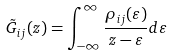<formula> <loc_0><loc_0><loc_500><loc_500>\tilde { G } _ { i j } ( z ) = \int _ { - \infty } ^ { \infty } \frac { \rho _ { i j } ( \varepsilon ) } { z - \varepsilon } d \varepsilon</formula> 